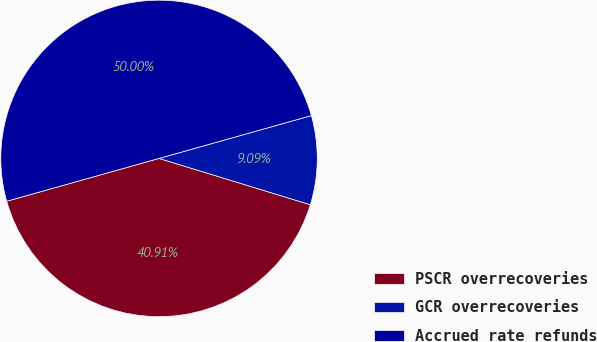Convert chart to OTSL. <chart><loc_0><loc_0><loc_500><loc_500><pie_chart><fcel>PSCR overrecoveries<fcel>GCR overrecoveries<fcel>Accrued rate refunds<nl><fcel>40.91%<fcel>9.09%<fcel>50.0%<nl></chart> 